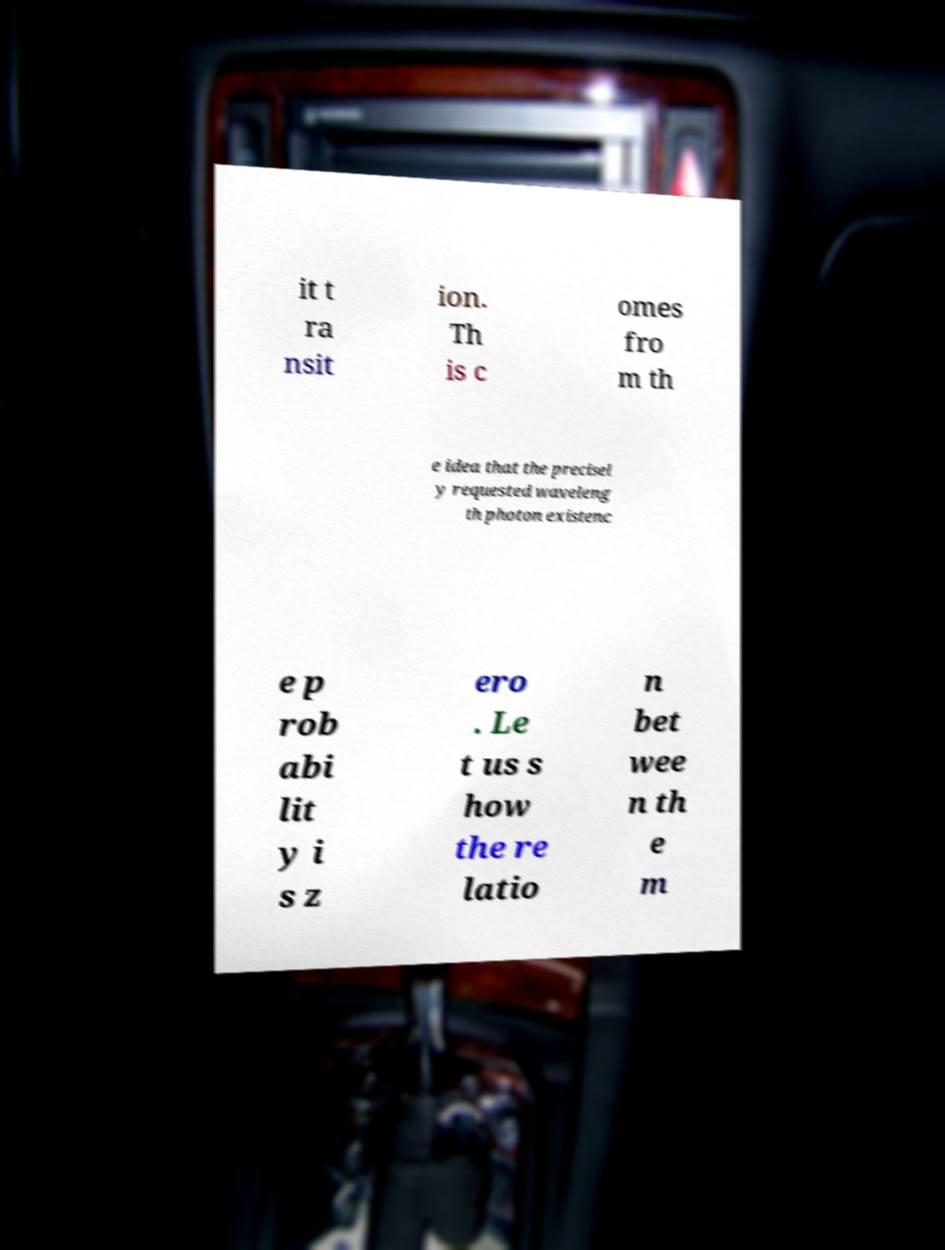For documentation purposes, I need the text within this image transcribed. Could you provide that? it t ra nsit ion. Th is c omes fro m th e idea that the precisel y requested waveleng th photon existenc e p rob abi lit y i s z ero . Le t us s how the re latio n bet wee n th e m 